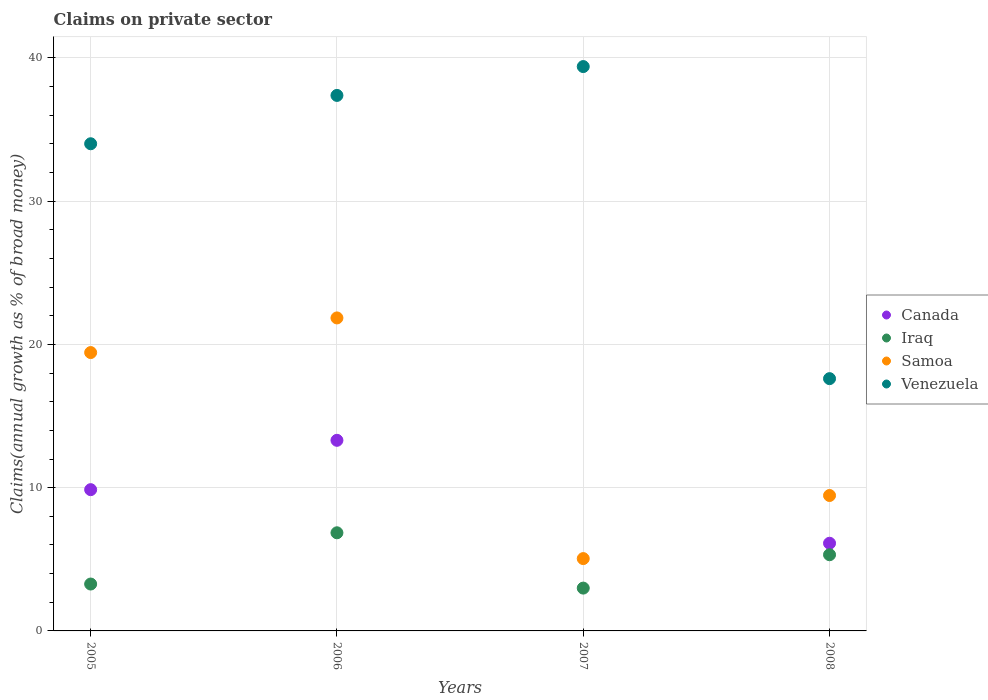What is the percentage of broad money claimed on private sector in Iraq in 2005?
Your answer should be very brief. 3.27. Across all years, what is the maximum percentage of broad money claimed on private sector in Canada?
Make the answer very short. 13.31. Across all years, what is the minimum percentage of broad money claimed on private sector in Iraq?
Your response must be concise. 2.99. In which year was the percentage of broad money claimed on private sector in Canada maximum?
Keep it short and to the point. 2006. What is the total percentage of broad money claimed on private sector in Venezuela in the graph?
Your answer should be very brief. 128.39. What is the difference between the percentage of broad money claimed on private sector in Canada in 2006 and that in 2008?
Your response must be concise. 7.19. What is the difference between the percentage of broad money claimed on private sector in Samoa in 2006 and the percentage of broad money claimed on private sector in Venezuela in 2005?
Provide a short and direct response. -12.16. What is the average percentage of broad money claimed on private sector in Canada per year?
Your answer should be very brief. 7.32. In the year 2005, what is the difference between the percentage of broad money claimed on private sector in Iraq and percentage of broad money claimed on private sector in Venezuela?
Offer a terse response. -30.73. What is the ratio of the percentage of broad money claimed on private sector in Samoa in 2005 to that in 2008?
Make the answer very short. 2.06. Is the percentage of broad money claimed on private sector in Samoa in 2006 less than that in 2007?
Your response must be concise. No. Is the difference between the percentage of broad money claimed on private sector in Iraq in 2007 and 2008 greater than the difference between the percentage of broad money claimed on private sector in Venezuela in 2007 and 2008?
Offer a terse response. No. What is the difference between the highest and the second highest percentage of broad money claimed on private sector in Iraq?
Your answer should be compact. 1.53. What is the difference between the highest and the lowest percentage of broad money claimed on private sector in Canada?
Keep it short and to the point. 13.31. In how many years, is the percentage of broad money claimed on private sector in Canada greater than the average percentage of broad money claimed on private sector in Canada taken over all years?
Offer a very short reply. 2. Is it the case that in every year, the sum of the percentage of broad money claimed on private sector in Canada and percentage of broad money claimed on private sector in Iraq  is greater than the percentage of broad money claimed on private sector in Venezuela?
Make the answer very short. No. Is the percentage of broad money claimed on private sector in Canada strictly less than the percentage of broad money claimed on private sector in Venezuela over the years?
Offer a very short reply. Yes. Does the graph contain any zero values?
Make the answer very short. Yes. Where does the legend appear in the graph?
Your answer should be compact. Center right. How are the legend labels stacked?
Your answer should be compact. Vertical. What is the title of the graph?
Your response must be concise. Claims on private sector. Does "South Sudan" appear as one of the legend labels in the graph?
Keep it short and to the point. No. What is the label or title of the Y-axis?
Your answer should be very brief. Claims(annual growth as % of broad money). What is the Claims(annual growth as % of broad money) in Canada in 2005?
Offer a terse response. 9.86. What is the Claims(annual growth as % of broad money) of Iraq in 2005?
Make the answer very short. 3.27. What is the Claims(annual growth as % of broad money) in Samoa in 2005?
Make the answer very short. 19.43. What is the Claims(annual growth as % of broad money) in Venezuela in 2005?
Provide a short and direct response. 34.01. What is the Claims(annual growth as % of broad money) of Canada in 2006?
Make the answer very short. 13.31. What is the Claims(annual growth as % of broad money) of Iraq in 2006?
Keep it short and to the point. 6.85. What is the Claims(annual growth as % of broad money) in Samoa in 2006?
Make the answer very short. 21.85. What is the Claims(annual growth as % of broad money) of Venezuela in 2006?
Make the answer very short. 37.38. What is the Claims(annual growth as % of broad money) in Iraq in 2007?
Provide a short and direct response. 2.99. What is the Claims(annual growth as % of broad money) in Samoa in 2007?
Give a very brief answer. 5.05. What is the Claims(annual growth as % of broad money) in Venezuela in 2007?
Keep it short and to the point. 39.39. What is the Claims(annual growth as % of broad money) of Canada in 2008?
Keep it short and to the point. 6.12. What is the Claims(annual growth as % of broad money) of Iraq in 2008?
Keep it short and to the point. 5.32. What is the Claims(annual growth as % of broad money) in Samoa in 2008?
Your answer should be very brief. 9.45. What is the Claims(annual growth as % of broad money) of Venezuela in 2008?
Ensure brevity in your answer.  17.61. Across all years, what is the maximum Claims(annual growth as % of broad money) in Canada?
Ensure brevity in your answer.  13.31. Across all years, what is the maximum Claims(annual growth as % of broad money) in Iraq?
Give a very brief answer. 6.85. Across all years, what is the maximum Claims(annual growth as % of broad money) in Samoa?
Your response must be concise. 21.85. Across all years, what is the maximum Claims(annual growth as % of broad money) in Venezuela?
Provide a succinct answer. 39.39. Across all years, what is the minimum Claims(annual growth as % of broad money) of Canada?
Keep it short and to the point. 0. Across all years, what is the minimum Claims(annual growth as % of broad money) in Iraq?
Make the answer very short. 2.99. Across all years, what is the minimum Claims(annual growth as % of broad money) of Samoa?
Keep it short and to the point. 5.05. Across all years, what is the minimum Claims(annual growth as % of broad money) in Venezuela?
Give a very brief answer. 17.61. What is the total Claims(annual growth as % of broad money) of Canada in the graph?
Offer a very short reply. 29.29. What is the total Claims(annual growth as % of broad money) in Iraq in the graph?
Offer a terse response. 18.43. What is the total Claims(annual growth as % of broad money) of Samoa in the graph?
Provide a succinct answer. 55.78. What is the total Claims(annual growth as % of broad money) in Venezuela in the graph?
Make the answer very short. 128.39. What is the difference between the Claims(annual growth as % of broad money) of Canada in 2005 and that in 2006?
Give a very brief answer. -3.44. What is the difference between the Claims(annual growth as % of broad money) in Iraq in 2005 and that in 2006?
Offer a terse response. -3.58. What is the difference between the Claims(annual growth as % of broad money) of Samoa in 2005 and that in 2006?
Your answer should be very brief. -2.42. What is the difference between the Claims(annual growth as % of broad money) of Venezuela in 2005 and that in 2006?
Your response must be concise. -3.37. What is the difference between the Claims(annual growth as % of broad money) of Iraq in 2005 and that in 2007?
Offer a terse response. 0.28. What is the difference between the Claims(annual growth as % of broad money) in Samoa in 2005 and that in 2007?
Your answer should be very brief. 14.38. What is the difference between the Claims(annual growth as % of broad money) of Venezuela in 2005 and that in 2007?
Your answer should be compact. -5.39. What is the difference between the Claims(annual growth as % of broad money) of Canada in 2005 and that in 2008?
Provide a succinct answer. 3.74. What is the difference between the Claims(annual growth as % of broad money) of Iraq in 2005 and that in 2008?
Provide a short and direct response. -2.04. What is the difference between the Claims(annual growth as % of broad money) of Samoa in 2005 and that in 2008?
Your response must be concise. 9.98. What is the difference between the Claims(annual growth as % of broad money) in Venezuela in 2005 and that in 2008?
Your answer should be compact. 16.4. What is the difference between the Claims(annual growth as % of broad money) in Iraq in 2006 and that in 2007?
Provide a short and direct response. 3.86. What is the difference between the Claims(annual growth as % of broad money) in Samoa in 2006 and that in 2007?
Give a very brief answer. 16.8. What is the difference between the Claims(annual growth as % of broad money) in Venezuela in 2006 and that in 2007?
Make the answer very short. -2.01. What is the difference between the Claims(annual growth as % of broad money) of Canada in 2006 and that in 2008?
Give a very brief answer. 7.18. What is the difference between the Claims(annual growth as % of broad money) of Iraq in 2006 and that in 2008?
Offer a terse response. 1.53. What is the difference between the Claims(annual growth as % of broad money) of Samoa in 2006 and that in 2008?
Provide a short and direct response. 12.4. What is the difference between the Claims(annual growth as % of broad money) of Venezuela in 2006 and that in 2008?
Give a very brief answer. 19.77. What is the difference between the Claims(annual growth as % of broad money) of Iraq in 2007 and that in 2008?
Offer a very short reply. -2.33. What is the difference between the Claims(annual growth as % of broad money) in Samoa in 2007 and that in 2008?
Your answer should be compact. -4.4. What is the difference between the Claims(annual growth as % of broad money) of Venezuela in 2007 and that in 2008?
Offer a very short reply. 21.78. What is the difference between the Claims(annual growth as % of broad money) of Canada in 2005 and the Claims(annual growth as % of broad money) of Iraq in 2006?
Keep it short and to the point. 3.01. What is the difference between the Claims(annual growth as % of broad money) of Canada in 2005 and the Claims(annual growth as % of broad money) of Samoa in 2006?
Offer a terse response. -11.99. What is the difference between the Claims(annual growth as % of broad money) of Canada in 2005 and the Claims(annual growth as % of broad money) of Venezuela in 2006?
Provide a succinct answer. -27.52. What is the difference between the Claims(annual growth as % of broad money) of Iraq in 2005 and the Claims(annual growth as % of broad money) of Samoa in 2006?
Your answer should be compact. -18.57. What is the difference between the Claims(annual growth as % of broad money) in Iraq in 2005 and the Claims(annual growth as % of broad money) in Venezuela in 2006?
Offer a terse response. -34.11. What is the difference between the Claims(annual growth as % of broad money) in Samoa in 2005 and the Claims(annual growth as % of broad money) in Venezuela in 2006?
Keep it short and to the point. -17.95. What is the difference between the Claims(annual growth as % of broad money) in Canada in 2005 and the Claims(annual growth as % of broad money) in Iraq in 2007?
Offer a terse response. 6.87. What is the difference between the Claims(annual growth as % of broad money) in Canada in 2005 and the Claims(annual growth as % of broad money) in Samoa in 2007?
Your answer should be compact. 4.81. What is the difference between the Claims(annual growth as % of broad money) in Canada in 2005 and the Claims(annual growth as % of broad money) in Venezuela in 2007?
Your answer should be very brief. -29.53. What is the difference between the Claims(annual growth as % of broad money) in Iraq in 2005 and the Claims(annual growth as % of broad money) in Samoa in 2007?
Provide a succinct answer. -1.78. What is the difference between the Claims(annual growth as % of broad money) of Iraq in 2005 and the Claims(annual growth as % of broad money) of Venezuela in 2007?
Offer a very short reply. -36.12. What is the difference between the Claims(annual growth as % of broad money) in Samoa in 2005 and the Claims(annual growth as % of broad money) in Venezuela in 2007?
Give a very brief answer. -19.96. What is the difference between the Claims(annual growth as % of broad money) in Canada in 2005 and the Claims(annual growth as % of broad money) in Iraq in 2008?
Your answer should be very brief. 4.54. What is the difference between the Claims(annual growth as % of broad money) of Canada in 2005 and the Claims(annual growth as % of broad money) of Samoa in 2008?
Your answer should be compact. 0.41. What is the difference between the Claims(annual growth as % of broad money) in Canada in 2005 and the Claims(annual growth as % of broad money) in Venezuela in 2008?
Offer a very short reply. -7.75. What is the difference between the Claims(annual growth as % of broad money) of Iraq in 2005 and the Claims(annual growth as % of broad money) of Samoa in 2008?
Your response must be concise. -6.18. What is the difference between the Claims(annual growth as % of broad money) of Iraq in 2005 and the Claims(annual growth as % of broad money) of Venezuela in 2008?
Make the answer very short. -14.34. What is the difference between the Claims(annual growth as % of broad money) of Samoa in 2005 and the Claims(annual growth as % of broad money) of Venezuela in 2008?
Your response must be concise. 1.82. What is the difference between the Claims(annual growth as % of broad money) of Canada in 2006 and the Claims(annual growth as % of broad money) of Iraq in 2007?
Your answer should be compact. 10.32. What is the difference between the Claims(annual growth as % of broad money) in Canada in 2006 and the Claims(annual growth as % of broad money) in Samoa in 2007?
Offer a very short reply. 8.26. What is the difference between the Claims(annual growth as % of broad money) of Canada in 2006 and the Claims(annual growth as % of broad money) of Venezuela in 2007?
Your answer should be compact. -26.09. What is the difference between the Claims(annual growth as % of broad money) in Iraq in 2006 and the Claims(annual growth as % of broad money) in Samoa in 2007?
Provide a succinct answer. 1.8. What is the difference between the Claims(annual growth as % of broad money) in Iraq in 2006 and the Claims(annual growth as % of broad money) in Venezuela in 2007?
Offer a terse response. -32.54. What is the difference between the Claims(annual growth as % of broad money) in Samoa in 2006 and the Claims(annual growth as % of broad money) in Venezuela in 2007?
Give a very brief answer. -17.55. What is the difference between the Claims(annual growth as % of broad money) in Canada in 2006 and the Claims(annual growth as % of broad money) in Iraq in 2008?
Give a very brief answer. 7.99. What is the difference between the Claims(annual growth as % of broad money) of Canada in 2006 and the Claims(annual growth as % of broad money) of Samoa in 2008?
Make the answer very short. 3.85. What is the difference between the Claims(annual growth as % of broad money) of Canada in 2006 and the Claims(annual growth as % of broad money) of Venezuela in 2008?
Ensure brevity in your answer.  -4.3. What is the difference between the Claims(annual growth as % of broad money) of Iraq in 2006 and the Claims(annual growth as % of broad money) of Samoa in 2008?
Ensure brevity in your answer.  -2.6. What is the difference between the Claims(annual growth as % of broad money) in Iraq in 2006 and the Claims(annual growth as % of broad money) in Venezuela in 2008?
Make the answer very short. -10.76. What is the difference between the Claims(annual growth as % of broad money) in Samoa in 2006 and the Claims(annual growth as % of broad money) in Venezuela in 2008?
Your answer should be compact. 4.24. What is the difference between the Claims(annual growth as % of broad money) in Iraq in 2007 and the Claims(annual growth as % of broad money) in Samoa in 2008?
Your response must be concise. -6.46. What is the difference between the Claims(annual growth as % of broad money) in Iraq in 2007 and the Claims(annual growth as % of broad money) in Venezuela in 2008?
Offer a very short reply. -14.62. What is the difference between the Claims(annual growth as % of broad money) of Samoa in 2007 and the Claims(annual growth as % of broad money) of Venezuela in 2008?
Offer a terse response. -12.56. What is the average Claims(annual growth as % of broad money) of Canada per year?
Offer a very short reply. 7.32. What is the average Claims(annual growth as % of broad money) of Iraq per year?
Your answer should be compact. 4.61. What is the average Claims(annual growth as % of broad money) in Samoa per year?
Your response must be concise. 13.94. What is the average Claims(annual growth as % of broad money) of Venezuela per year?
Make the answer very short. 32.1. In the year 2005, what is the difference between the Claims(annual growth as % of broad money) in Canada and Claims(annual growth as % of broad money) in Iraq?
Provide a short and direct response. 6.59. In the year 2005, what is the difference between the Claims(annual growth as % of broad money) of Canada and Claims(annual growth as % of broad money) of Samoa?
Your answer should be compact. -9.57. In the year 2005, what is the difference between the Claims(annual growth as % of broad money) of Canada and Claims(annual growth as % of broad money) of Venezuela?
Your answer should be compact. -24.14. In the year 2005, what is the difference between the Claims(annual growth as % of broad money) of Iraq and Claims(annual growth as % of broad money) of Samoa?
Offer a very short reply. -16.16. In the year 2005, what is the difference between the Claims(annual growth as % of broad money) of Iraq and Claims(annual growth as % of broad money) of Venezuela?
Make the answer very short. -30.73. In the year 2005, what is the difference between the Claims(annual growth as % of broad money) of Samoa and Claims(annual growth as % of broad money) of Venezuela?
Offer a very short reply. -14.57. In the year 2006, what is the difference between the Claims(annual growth as % of broad money) in Canada and Claims(annual growth as % of broad money) in Iraq?
Provide a succinct answer. 6.46. In the year 2006, what is the difference between the Claims(annual growth as % of broad money) of Canada and Claims(annual growth as % of broad money) of Samoa?
Offer a very short reply. -8.54. In the year 2006, what is the difference between the Claims(annual growth as % of broad money) in Canada and Claims(annual growth as % of broad money) in Venezuela?
Offer a terse response. -24.07. In the year 2006, what is the difference between the Claims(annual growth as % of broad money) of Iraq and Claims(annual growth as % of broad money) of Samoa?
Your response must be concise. -15. In the year 2006, what is the difference between the Claims(annual growth as % of broad money) in Iraq and Claims(annual growth as % of broad money) in Venezuela?
Ensure brevity in your answer.  -30.53. In the year 2006, what is the difference between the Claims(annual growth as % of broad money) of Samoa and Claims(annual growth as % of broad money) of Venezuela?
Your answer should be compact. -15.53. In the year 2007, what is the difference between the Claims(annual growth as % of broad money) of Iraq and Claims(annual growth as % of broad money) of Samoa?
Provide a short and direct response. -2.06. In the year 2007, what is the difference between the Claims(annual growth as % of broad money) of Iraq and Claims(annual growth as % of broad money) of Venezuela?
Your answer should be very brief. -36.4. In the year 2007, what is the difference between the Claims(annual growth as % of broad money) in Samoa and Claims(annual growth as % of broad money) in Venezuela?
Your answer should be very brief. -34.34. In the year 2008, what is the difference between the Claims(annual growth as % of broad money) of Canada and Claims(annual growth as % of broad money) of Iraq?
Provide a short and direct response. 0.8. In the year 2008, what is the difference between the Claims(annual growth as % of broad money) in Canada and Claims(annual growth as % of broad money) in Samoa?
Offer a terse response. -3.33. In the year 2008, what is the difference between the Claims(annual growth as % of broad money) of Canada and Claims(annual growth as % of broad money) of Venezuela?
Provide a succinct answer. -11.49. In the year 2008, what is the difference between the Claims(annual growth as % of broad money) of Iraq and Claims(annual growth as % of broad money) of Samoa?
Offer a terse response. -4.13. In the year 2008, what is the difference between the Claims(annual growth as % of broad money) in Iraq and Claims(annual growth as % of broad money) in Venezuela?
Make the answer very short. -12.29. In the year 2008, what is the difference between the Claims(annual growth as % of broad money) of Samoa and Claims(annual growth as % of broad money) of Venezuela?
Your answer should be compact. -8.16. What is the ratio of the Claims(annual growth as % of broad money) of Canada in 2005 to that in 2006?
Give a very brief answer. 0.74. What is the ratio of the Claims(annual growth as % of broad money) of Iraq in 2005 to that in 2006?
Your answer should be very brief. 0.48. What is the ratio of the Claims(annual growth as % of broad money) in Samoa in 2005 to that in 2006?
Ensure brevity in your answer.  0.89. What is the ratio of the Claims(annual growth as % of broad money) of Venezuela in 2005 to that in 2006?
Your answer should be compact. 0.91. What is the ratio of the Claims(annual growth as % of broad money) in Iraq in 2005 to that in 2007?
Ensure brevity in your answer.  1.1. What is the ratio of the Claims(annual growth as % of broad money) of Samoa in 2005 to that in 2007?
Offer a terse response. 3.85. What is the ratio of the Claims(annual growth as % of broad money) in Venezuela in 2005 to that in 2007?
Your answer should be compact. 0.86. What is the ratio of the Claims(annual growth as % of broad money) in Canada in 2005 to that in 2008?
Give a very brief answer. 1.61. What is the ratio of the Claims(annual growth as % of broad money) of Iraq in 2005 to that in 2008?
Your response must be concise. 0.62. What is the ratio of the Claims(annual growth as % of broad money) of Samoa in 2005 to that in 2008?
Your response must be concise. 2.06. What is the ratio of the Claims(annual growth as % of broad money) of Venezuela in 2005 to that in 2008?
Keep it short and to the point. 1.93. What is the ratio of the Claims(annual growth as % of broad money) in Iraq in 2006 to that in 2007?
Keep it short and to the point. 2.29. What is the ratio of the Claims(annual growth as % of broad money) of Samoa in 2006 to that in 2007?
Your response must be concise. 4.33. What is the ratio of the Claims(annual growth as % of broad money) of Venezuela in 2006 to that in 2007?
Offer a very short reply. 0.95. What is the ratio of the Claims(annual growth as % of broad money) of Canada in 2006 to that in 2008?
Provide a succinct answer. 2.17. What is the ratio of the Claims(annual growth as % of broad money) of Iraq in 2006 to that in 2008?
Ensure brevity in your answer.  1.29. What is the ratio of the Claims(annual growth as % of broad money) of Samoa in 2006 to that in 2008?
Make the answer very short. 2.31. What is the ratio of the Claims(annual growth as % of broad money) in Venezuela in 2006 to that in 2008?
Ensure brevity in your answer.  2.12. What is the ratio of the Claims(annual growth as % of broad money) of Iraq in 2007 to that in 2008?
Offer a very short reply. 0.56. What is the ratio of the Claims(annual growth as % of broad money) of Samoa in 2007 to that in 2008?
Provide a succinct answer. 0.53. What is the ratio of the Claims(annual growth as % of broad money) of Venezuela in 2007 to that in 2008?
Provide a short and direct response. 2.24. What is the difference between the highest and the second highest Claims(annual growth as % of broad money) of Canada?
Ensure brevity in your answer.  3.44. What is the difference between the highest and the second highest Claims(annual growth as % of broad money) of Iraq?
Your answer should be compact. 1.53. What is the difference between the highest and the second highest Claims(annual growth as % of broad money) in Samoa?
Keep it short and to the point. 2.42. What is the difference between the highest and the second highest Claims(annual growth as % of broad money) of Venezuela?
Your answer should be compact. 2.01. What is the difference between the highest and the lowest Claims(annual growth as % of broad money) in Canada?
Provide a succinct answer. 13.3. What is the difference between the highest and the lowest Claims(annual growth as % of broad money) of Iraq?
Keep it short and to the point. 3.86. What is the difference between the highest and the lowest Claims(annual growth as % of broad money) in Samoa?
Offer a terse response. 16.8. What is the difference between the highest and the lowest Claims(annual growth as % of broad money) in Venezuela?
Make the answer very short. 21.78. 